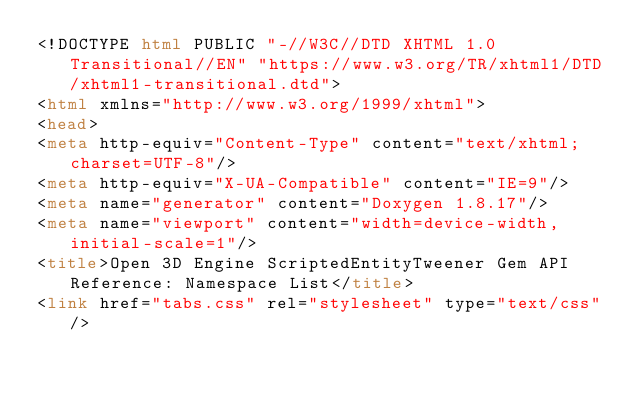Convert code to text. <code><loc_0><loc_0><loc_500><loc_500><_HTML_><!DOCTYPE html PUBLIC "-//W3C//DTD XHTML 1.0 Transitional//EN" "https://www.w3.org/TR/xhtml1/DTD/xhtml1-transitional.dtd">
<html xmlns="http://www.w3.org/1999/xhtml">
<head>
<meta http-equiv="Content-Type" content="text/xhtml;charset=UTF-8"/>
<meta http-equiv="X-UA-Compatible" content="IE=9"/>
<meta name="generator" content="Doxygen 1.8.17"/>
<meta name="viewport" content="width=device-width, initial-scale=1"/>
<title>Open 3D Engine ScriptedEntityTweener Gem API Reference: Namespace List</title>
<link href="tabs.css" rel="stylesheet" type="text/css"/></code> 